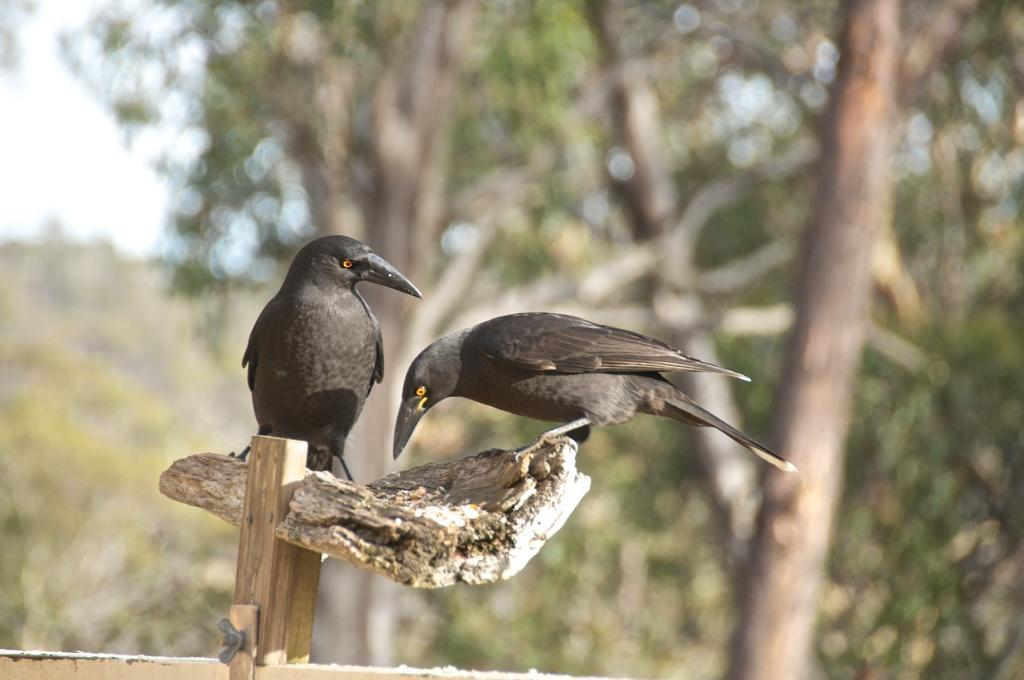How many birds can be seen in the image? There are two birds in the image. What type of surface are the birds on? The birds are on a wooden surface. What color are the birds? The birds are black in color. What can be seen in the background of the image? There are many trees and a blurry sky visible in the background of the image. What type of glass is being used to build the lumber in the image? There is no glass or lumber present in the image; it features two black birds on a wooden surface with a background of trees and a blurry sky. 